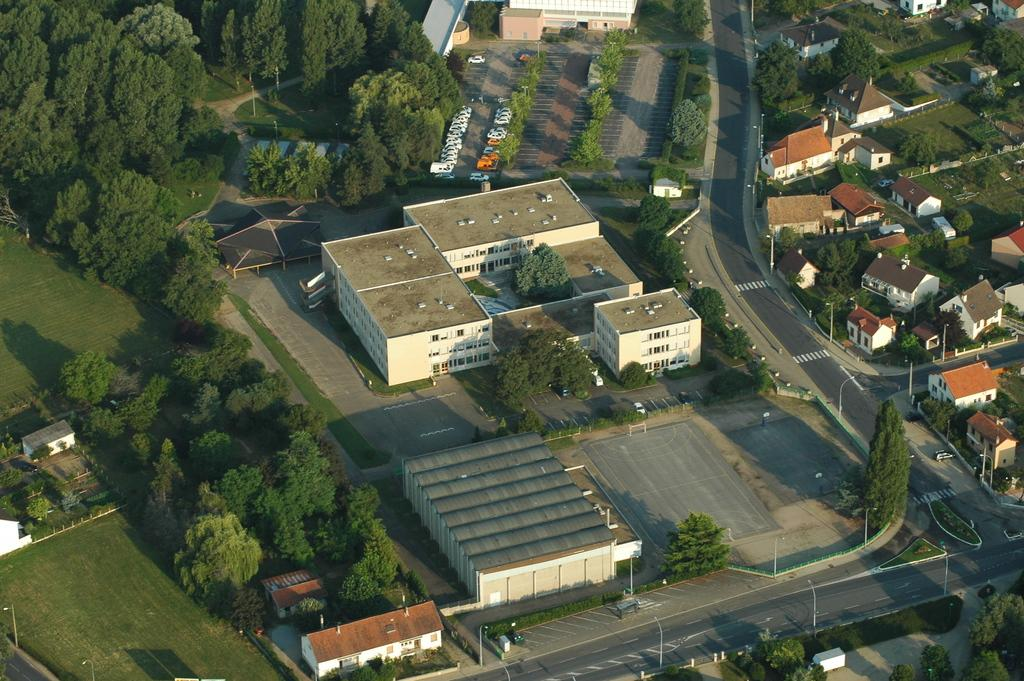What type of structures can be seen in the image? There are buildings and houses in the image. What is the path made of in the image? The path is not specified in the facts, so we cannot determine its material. What are the poles used for in the image? The facts do not specify the purpose of the poles, so we cannot determine their function. What type of vegetation is present in the image? There is green grass and trees in the image. What type of oil is being extracted from the trees in the image? There is no mention of oil or tree extraction in the image, so we cannot determine if any oil is being extracted. 